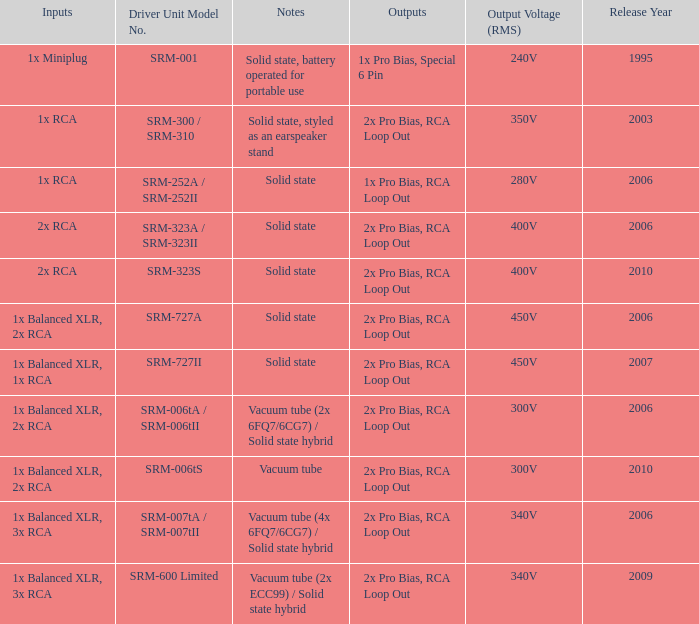How many results are there for solid state, battery-driven for portable use listed in notes? 1.0. 